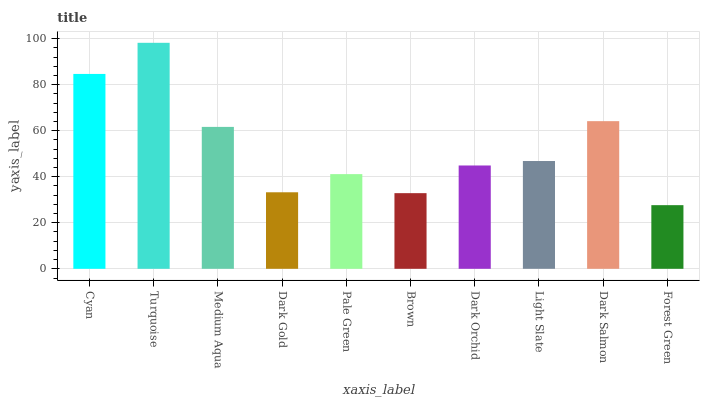Is Medium Aqua the minimum?
Answer yes or no. No. Is Medium Aqua the maximum?
Answer yes or no. No. Is Turquoise greater than Medium Aqua?
Answer yes or no. Yes. Is Medium Aqua less than Turquoise?
Answer yes or no. Yes. Is Medium Aqua greater than Turquoise?
Answer yes or no. No. Is Turquoise less than Medium Aqua?
Answer yes or no. No. Is Light Slate the high median?
Answer yes or no. Yes. Is Dark Orchid the low median?
Answer yes or no. Yes. Is Pale Green the high median?
Answer yes or no. No. Is Brown the low median?
Answer yes or no. No. 